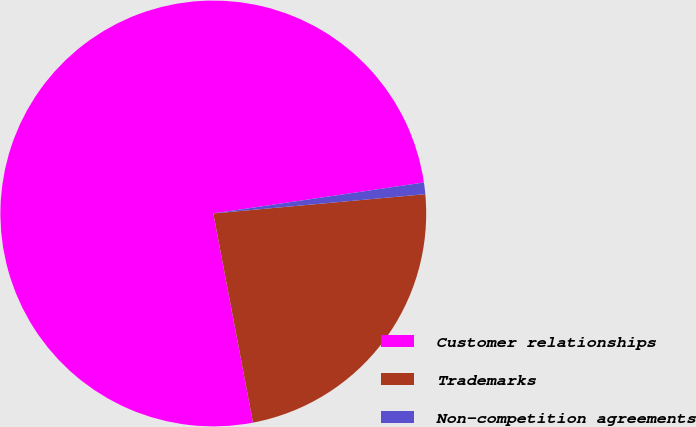Convert chart. <chart><loc_0><loc_0><loc_500><loc_500><pie_chart><fcel>Customer relationships<fcel>Trademarks<fcel>Non-competition agreements<nl><fcel>75.66%<fcel>23.46%<fcel>0.88%<nl></chart> 